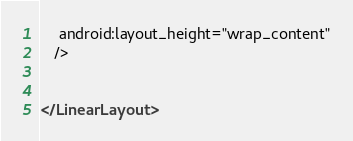Convert code to text. <code><loc_0><loc_0><loc_500><loc_500><_XML_>    android:layout_height="wrap_content"
   />


</LinearLayout>
</code> 